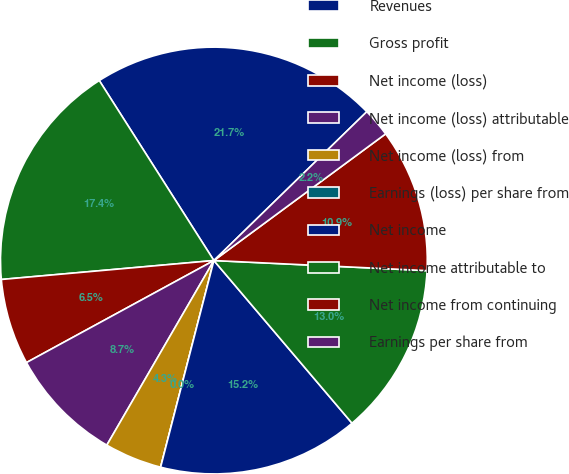Convert chart. <chart><loc_0><loc_0><loc_500><loc_500><pie_chart><fcel>Revenues<fcel>Gross profit<fcel>Net income (loss)<fcel>Net income (loss) attributable<fcel>Net income (loss) from<fcel>Earnings (loss) per share from<fcel>Net income<fcel>Net income attributable to<fcel>Net income from continuing<fcel>Earnings per share from<nl><fcel>21.74%<fcel>17.39%<fcel>6.52%<fcel>8.7%<fcel>4.35%<fcel>0.0%<fcel>15.22%<fcel>13.04%<fcel>10.87%<fcel>2.17%<nl></chart> 